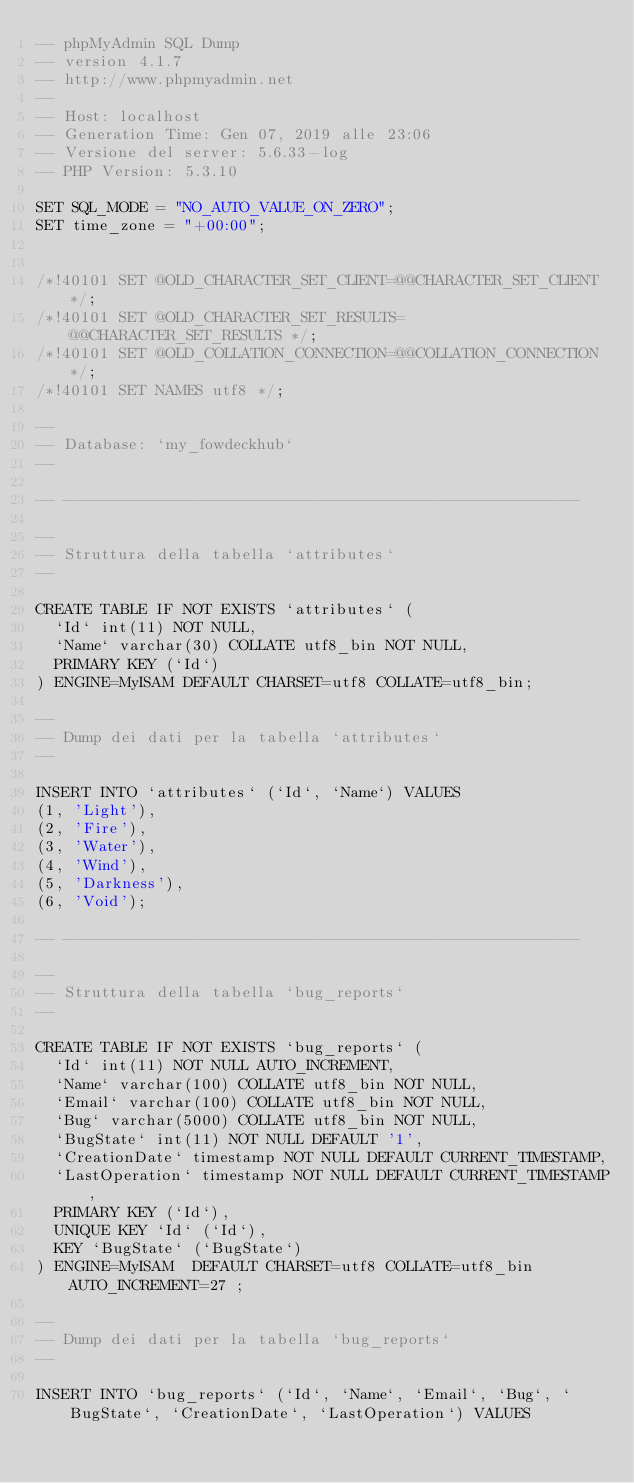Convert code to text. <code><loc_0><loc_0><loc_500><loc_500><_SQL_>-- phpMyAdmin SQL Dump
-- version 4.1.7
-- http://www.phpmyadmin.net
--
-- Host: localhost
-- Generation Time: Gen 07, 2019 alle 23:06
-- Versione del server: 5.6.33-log
-- PHP Version: 5.3.10

SET SQL_MODE = "NO_AUTO_VALUE_ON_ZERO";
SET time_zone = "+00:00";


/*!40101 SET @OLD_CHARACTER_SET_CLIENT=@@CHARACTER_SET_CLIENT */;
/*!40101 SET @OLD_CHARACTER_SET_RESULTS=@@CHARACTER_SET_RESULTS */;
/*!40101 SET @OLD_COLLATION_CONNECTION=@@COLLATION_CONNECTION */;
/*!40101 SET NAMES utf8 */;

--
-- Database: `my_fowdeckhub`
--

-- --------------------------------------------------------

--
-- Struttura della tabella `attributes`
--

CREATE TABLE IF NOT EXISTS `attributes` (
  `Id` int(11) NOT NULL,
  `Name` varchar(30) COLLATE utf8_bin NOT NULL,
  PRIMARY KEY (`Id`)
) ENGINE=MyISAM DEFAULT CHARSET=utf8 COLLATE=utf8_bin;

--
-- Dump dei dati per la tabella `attributes`
--

INSERT INTO `attributes` (`Id`, `Name`) VALUES
(1, 'Light'),
(2, 'Fire'),
(3, 'Water'),
(4, 'Wind'),
(5, 'Darkness'),
(6, 'Void');

-- --------------------------------------------------------

--
-- Struttura della tabella `bug_reports`
--

CREATE TABLE IF NOT EXISTS `bug_reports` (
  `Id` int(11) NOT NULL AUTO_INCREMENT,
  `Name` varchar(100) COLLATE utf8_bin NOT NULL,
  `Email` varchar(100) COLLATE utf8_bin NOT NULL,
  `Bug` varchar(5000) COLLATE utf8_bin NOT NULL,
  `BugState` int(11) NOT NULL DEFAULT '1',
  `CreationDate` timestamp NOT NULL DEFAULT CURRENT_TIMESTAMP,
  `LastOperation` timestamp NOT NULL DEFAULT CURRENT_TIMESTAMP,
  PRIMARY KEY (`Id`),
  UNIQUE KEY `Id` (`Id`),
  KEY `BugState` (`BugState`)
) ENGINE=MyISAM  DEFAULT CHARSET=utf8 COLLATE=utf8_bin AUTO_INCREMENT=27 ;

--
-- Dump dei dati per la tabella `bug_reports`
--

INSERT INTO `bug_reports` (`Id`, `Name`, `Email`, `Bug`, `BugState`, `CreationDate`, `LastOperation`) VALUES</code> 